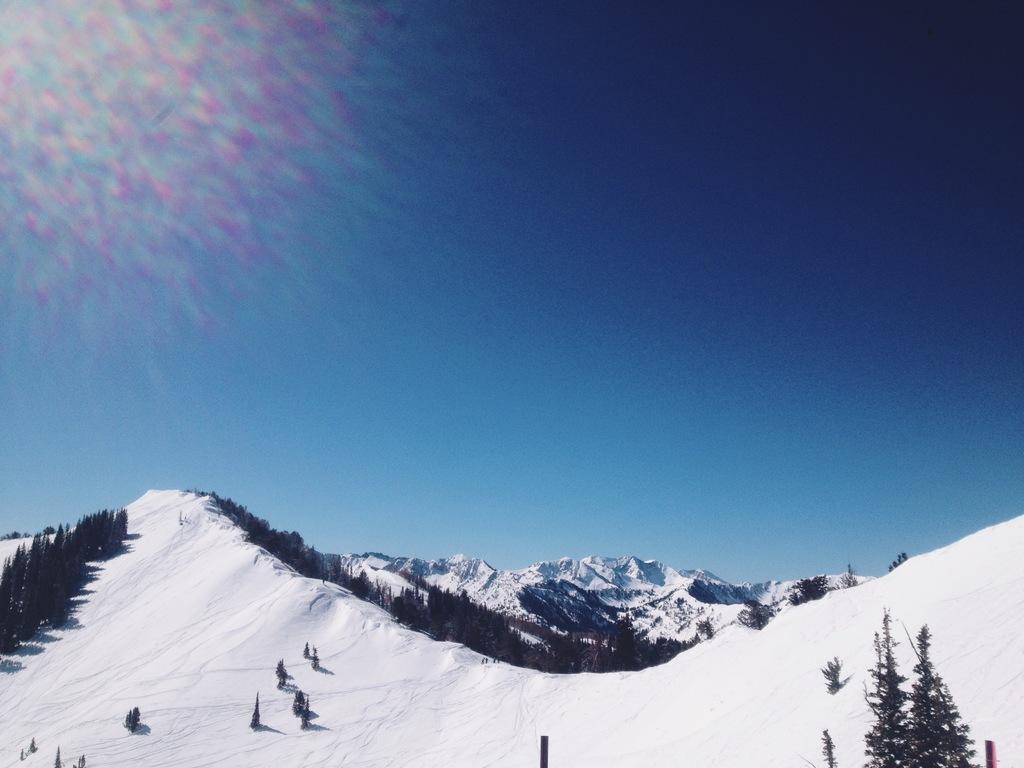Please provide a concise description of this image. In this picture we can see trees, snowy mountains and the sky. 